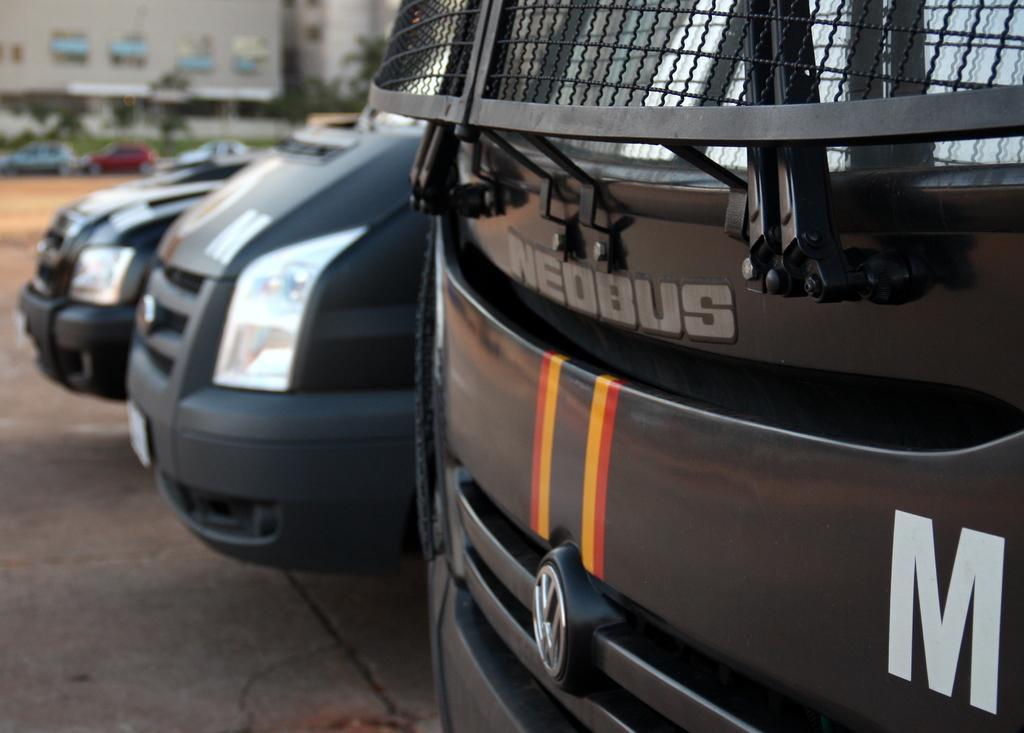In one or two sentences, can you explain what this image depicts? As we can see in the image there are vehicles, trees and buildings. 